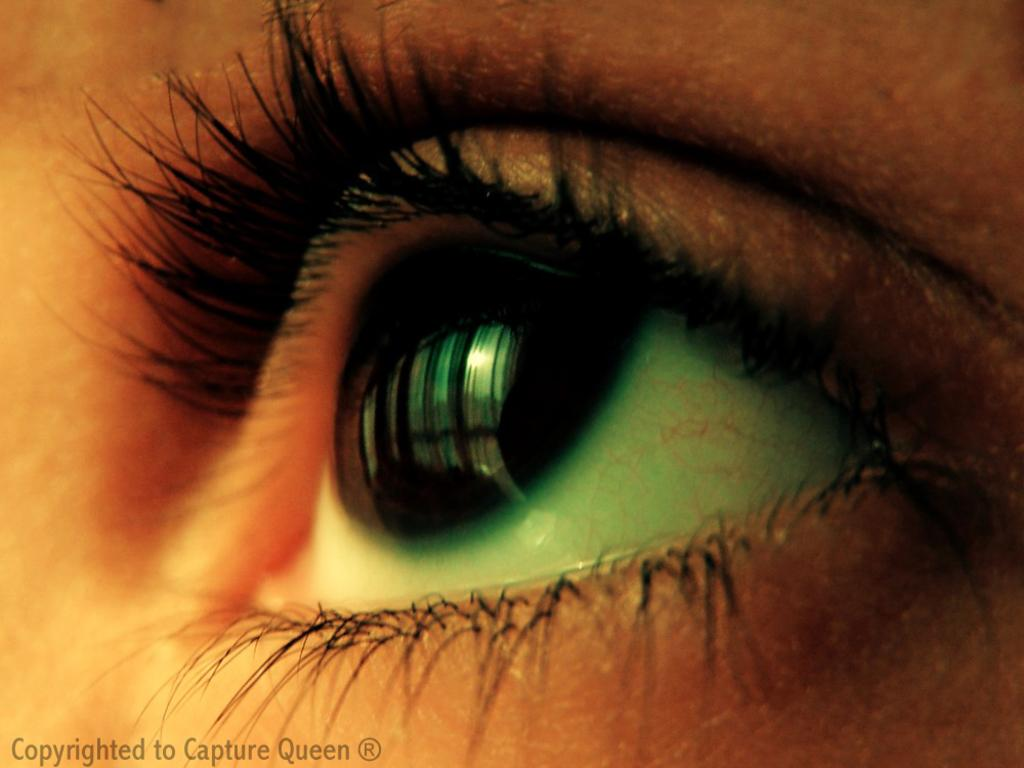What is the main subject of the image? The main subject of the image is the eye of a person. Is there any additional information or marking on the image? Yes, there is a watermark on the image. What type of pot is being used to store the facts in the image? There is no pot or storage of facts present in the image; it only features the eye of a person and a watermark. 